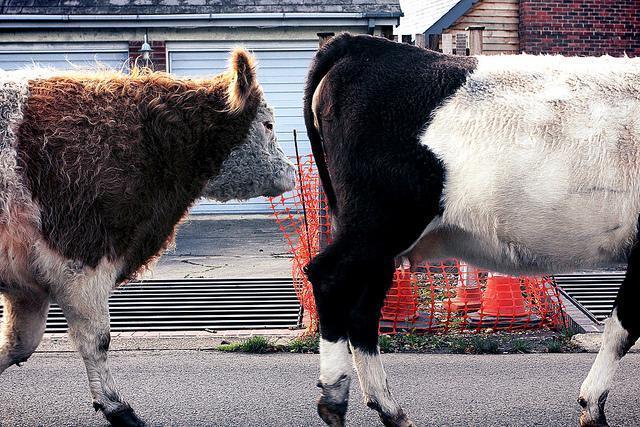How many cows are there?
Give a very brief answer. 2. 